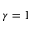<formula> <loc_0><loc_0><loc_500><loc_500>\gamma = 1</formula> 